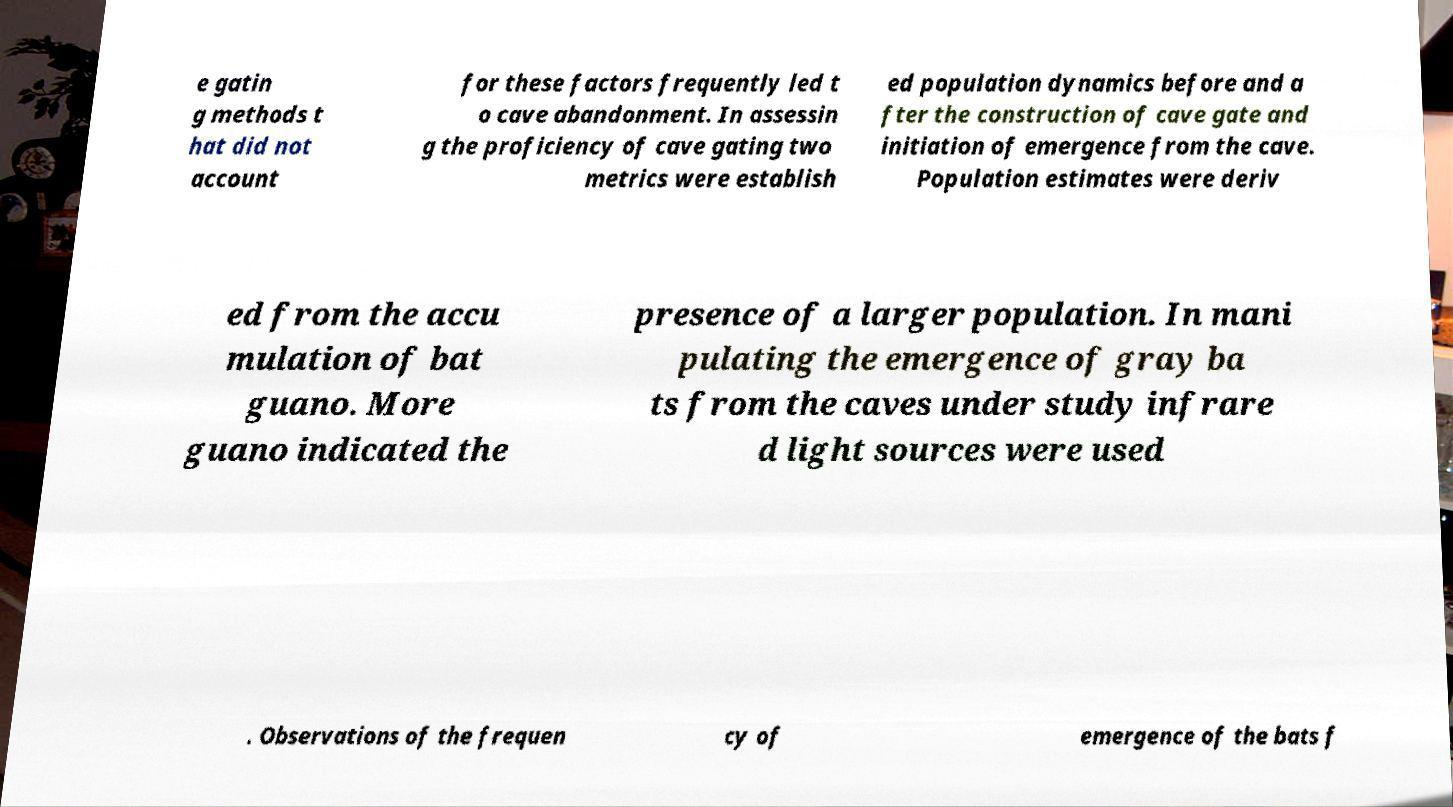Please identify and transcribe the text found in this image. e gatin g methods t hat did not account for these factors frequently led t o cave abandonment. In assessin g the proficiency of cave gating two metrics were establish ed population dynamics before and a fter the construction of cave gate and initiation of emergence from the cave. Population estimates were deriv ed from the accu mulation of bat guano. More guano indicated the presence of a larger population. In mani pulating the emergence of gray ba ts from the caves under study infrare d light sources were used . Observations of the frequen cy of emergence of the bats f 